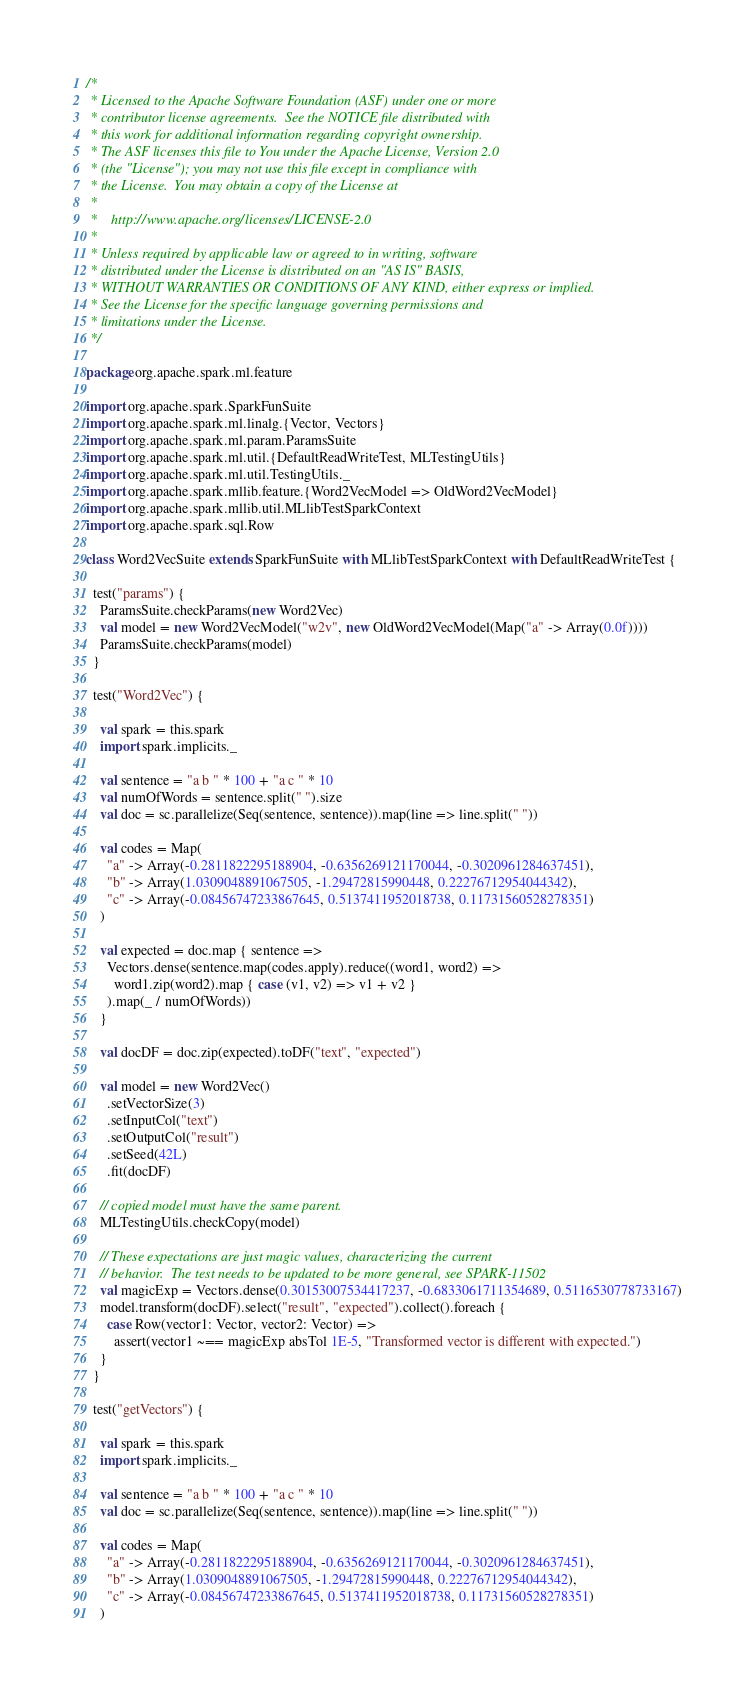<code> <loc_0><loc_0><loc_500><loc_500><_Scala_>/*
 * Licensed to the Apache Software Foundation (ASF) under one or more
 * contributor license agreements.  See the NOTICE file distributed with
 * this work for additional information regarding copyright ownership.
 * The ASF licenses this file to You under the Apache License, Version 2.0
 * (the "License"); you may not use this file except in compliance with
 * the License.  You may obtain a copy of the License at
 *
 *    http://www.apache.org/licenses/LICENSE-2.0
 *
 * Unless required by applicable law or agreed to in writing, software
 * distributed under the License is distributed on an "AS IS" BASIS,
 * WITHOUT WARRANTIES OR CONDITIONS OF ANY KIND, either express or implied.
 * See the License for the specific language governing permissions and
 * limitations under the License.
 */

package org.apache.spark.ml.feature

import org.apache.spark.SparkFunSuite
import org.apache.spark.ml.linalg.{Vector, Vectors}
import org.apache.spark.ml.param.ParamsSuite
import org.apache.spark.ml.util.{DefaultReadWriteTest, MLTestingUtils}
import org.apache.spark.ml.util.TestingUtils._
import org.apache.spark.mllib.feature.{Word2VecModel => OldWord2VecModel}
import org.apache.spark.mllib.util.MLlibTestSparkContext
import org.apache.spark.sql.Row

class Word2VecSuite extends SparkFunSuite with MLlibTestSparkContext with DefaultReadWriteTest {

  test("params") {
    ParamsSuite.checkParams(new Word2Vec)
    val model = new Word2VecModel("w2v", new OldWord2VecModel(Map("a" -> Array(0.0f))))
    ParamsSuite.checkParams(model)
  }

  test("Word2Vec") {

    val spark = this.spark
    import spark.implicits._

    val sentence = "a b " * 100 + "a c " * 10
    val numOfWords = sentence.split(" ").size
    val doc = sc.parallelize(Seq(sentence, sentence)).map(line => line.split(" "))

    val codes = Map(
      "a" -> Array(-0.2811822295188904, -0.6356269121170044, -0.3020961284637451),
      "b" -> Array(1.0309048891067505, -1.29472815990448, 0.22276712954044342),
      "c" -> Array(-0.08456747233867645, 0.5137411952018738, 0.11731560528278351)
    )

    val expected = doc.map { sentence =>
      Vectors.dense(sentence.map(codes.apply).reduce((word1, word2) =>
        word1.zip(word2).map { case (v1, v2) => v1 + v2 }
      ).map(_ / numOfWords))
    }

    val docDF = doc.zip(expected).toDF("text", "expected")

    val model = new Word2Vec()
      .setVectorSize(3)
      .setInputCol("text")
      .setOutputCol("result")
      .setSeed(42L)
      .fit(docDF)

    // copied model must have the same parent.
    MLTestingUtils.checkCopy(model)

    // These expectations are just magic values, characterizing the current
    // behavior.  The test needs to be updated to be more general, see SPARK-11502
    val magicExp = Vectors.dense(0.30153007534417237, -0.6833061711354689, 0.5116530778733167)
    model.transform(docDF).select("result", "expected").collect().foreach {
      case Row(vector1: Vector, vector2: Vector) =>
        assert(vector1 ~== magicExp absTol 1E-5, "Transformed vector is different with expected.")
    }
  }

  test("getVectors") {

    val spark = this.spark
    import spark.implicits._

    val sentence = "a b " * 100 + "a c " * 10
    val doc = sc.parallelize(Seq(sentence, sentence)).map(line => line.split(" "))

    val codes = Map(
      "a" -> Array(-0.2811822295188904, -0.6356269121170044, -0.3020961284637451),
      "b" -> Array(1.0309048891067505, -1.29472815990448, 0.22276712954044342),
      "c" -> Array(-0.08456747233867645, 0.5137411952018738, 0.11731560528278351)
    )</code> 